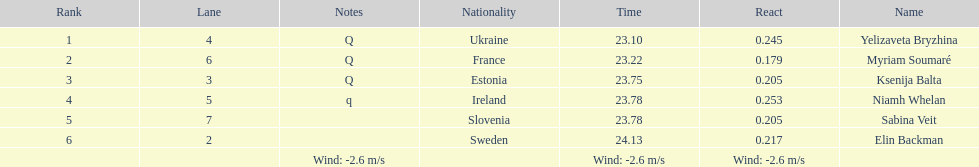Name of athlete who came in first in heat 1 of the women's 200 metres Yelizaveta Bryzhina. 